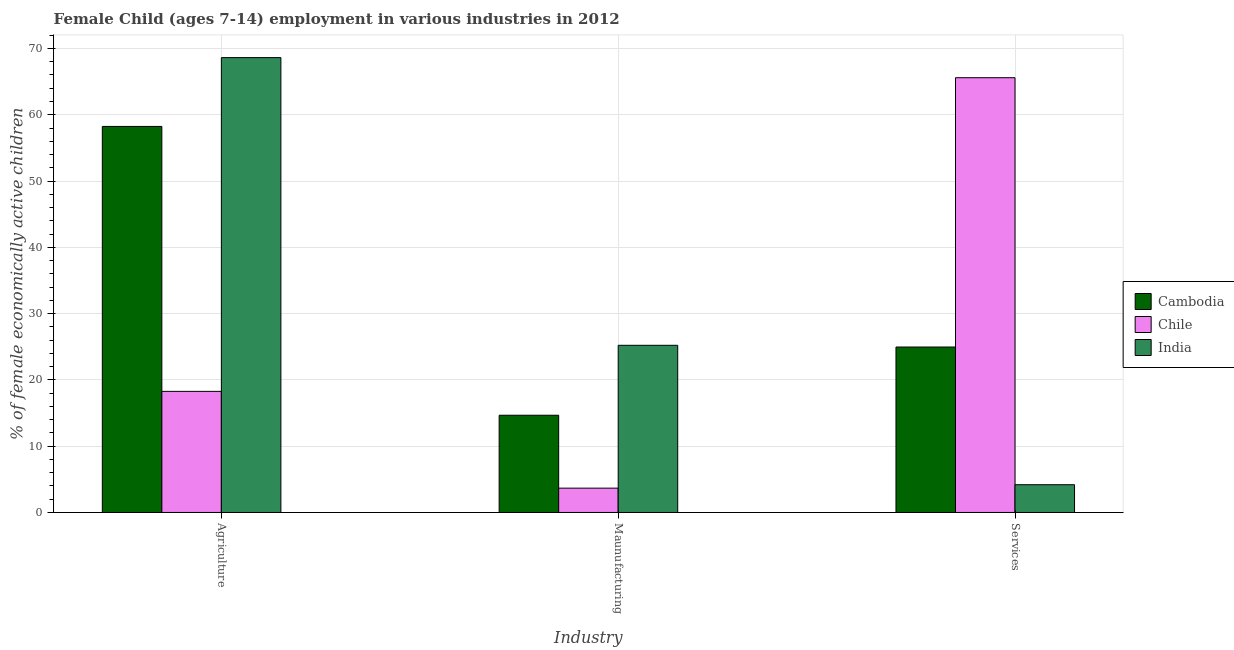How many groups of bars are there?
Give a very brief answer. 3. Are the number of bars per tick equal to the number of legend labels?
Your answer should be very brief. Yes. Are the number of bars on each tick of the X-axis equal?
Give a very brief answer. Yes. How many bars are there on the 1st tick from the left?
Your response must be concise. 3. What is the label of the 1st group of bars from the left?
Your answer should be compact. Agriculture. What is the percentage of economically active children in services in Chile?
Give a very brief answer. 65.59. Across all countries, what is the maximum percentage of economically active children in manufacturing?
Your answer should be very brief. 25.22. Across all countries, what is the minimum percentage of economically active children in agriculture?
Provide a succinct answer. 18.27. What is the total percentage of economically active children in manufacturing in the graph?
Offer a very short reply. 43.56. What is the difference between the percentage of economically active children in agriculture in Chile and that in India?
Offer a very short reply. -50.35. What is the difference between the percentage of economically active children in manufacturing in Chile and the percentage of economically active children in services in India?
Provide a succinct answer. -0.52. What is the average percentage of economically active children in manufacturing per country?
Your answer should be compact. 14.52. What is the difference between the percentage of economically active children in agriculture and percentage of economically active children in services in Cambodia?
Your response must be concise. 33.28. In how many countries, is the percentage of economically active children in services greater than 14 %?
Offer a very short reply. 2. What is the ratio of the percentage of economically active children in services in Cambodia to that in India?
Offer a terse response. 5.96. Is the percentage of economically active children in manufacturing in Cambodia less than that in India?
Offer a very short reply. Yes. Is the difference between the percentage of economically active children in manufacturing in Cambodia and India greater than the difference between the percentage of economically active children in agriculture in Cambodia and India?
Your answer should be very brief. No. What is the difference between the highest and the second highest percentage of economically active children in services?
Your answer should be compact. 40.63. What is the difference between the highest and the lowest percentage of economically active children in agriculture?
Give a very brief answer. 50.35. Is the sum of the percentage of economically active children in manufacturing in Cambodia and Chile greater than the maximum percentage of economically active children in services across all countries?
Your answer should be compact. No. What does the 3rd bar from the left in Services represents?
Your answer should be very brief. India. What does the 3rd bar from the right in Services represents?
Give a very brief answer. Cambodia. Is it the case that in every country, the sum of the percentage of economically active children in agriculture and percentage of economically active children in manufacturing is greater than the percentage of economically active children in services?
Provide a succinct answer. No. How many bars are there?
Your response must be concise. 9. Are all the bars in the graph horizontal?
Provide a succinct answer. No. How many countries are there in the graph?
Offer a very short reply. 3. What is the difference between two consecutive major ticks on the Y-axis?
Keep it short and to the point. 10. Are the values on the major ticks of Y-axis written in scientific E-notation?
Your answer should be compact. No. Does the graph contain any zero values?
Make the answer very short. No. Does the graph contain grids?
Make the answer very short. Yes. Where does the legend appear in the graph?
Give a very brief answer. Center right. What is the title of the graph?
Your answer should be very brief. Female Child (ages 7-14) employment in various industries in 2012. What is the label or title of the X-axis?
Give a very brief answer. Industry. What is the label or title of the Y-axis?
Offer a very short reply. % of female economically active children. What is the % of female economically active children of Cambodia in Agriculture?
Your answer should be very brief. 58.24. What is the % of female economically active children in Chile in Agriculture?
Keep it short and to the point. 18.27. What is the % of female economically active children in India in Agriculture?
Keep it short and to the point. 68.62. What is the % of female economically active children in Cambodia in Maunufacturing?
Keep it short and to the point. 14.67. What is the % of female economically active children of Chile in Maunufacturing?
Keep it short and to the point. 3.67. What is the % of female economically active children in India in Maunufacturing?
Make the answer very short. 25.22. What is the % of female economically active children of Cambodia in Services?
Offer a terse response. 24.96. What is the % of female economically active children in Chile in Services?
Give a very brief answer. 65.59. What is the % of female economically active children in India in Services?
Your answer should be compact. 4.19. Across all Industry, what is the maximum % of female economically active children in Cambodia?
Provide a short and direct response. 58.24. Across all Industry, what is the maximum % of female economically active children in Chile?
Provide a short and direct response. 65.59. Across all Industry, what is the maximum % of female economically active children in India?
Keep it short and to the point. 68.62. Across all Industry, what is the minimum % of female economically active children in Cambodia?
Offer a very short reply. 14.67. Across all Industry, what is the minimum % of female economically active children of Chile?
Keep it short and to the point. 3.67. Across all Industry, what is the minimum % of female economically active children in India?
Your answer should be very brief. 4.19. What is the total % of female economically active children in Cambodia in the graph?
Offer a terse response. 97.87. What is the total % of female economically active children of Chile in the graph?
Offer a very short reply. 87.53. What is the total % of female economically active children in India in the graph?
Offer a terse response. 98.03. What is the difference between the % of female economically active children of Cambodia in Agriculture and that in Maunufacturing?
Keep it short and to the point. 43.57. What is the difference between the % of female economically active children in Chile in Agriculture and that in Maunufacturing?
Your answer should be compact. 14.6. What is the difference between the % of female economically active children in India in Agriculture and that in Maunufacturing?
Provide a succinct answer. 43.4. What is the difference between the % of female economically active children of Cambodia in Agriculture and that in Services?
Offer a very short reply. 33.28. What is the difference between the % of female economically active children of Chile in Agriculture and that in Services?
Offer a terse response. -47.32. What is the difference between the % of female economically active children of India in Agriculture and that in Services?
Ensure brevity in your answer.  64.43. What is the difference between the % of female economically active children in Cambodia in Maunufacturing and that in Services?
Offer a very short reply. -10.29. What is the difference between the % of female economically active children in Chile in Maunufacturing and that in Services?
Offer a very short reply. -61.92. What is the difference between the % of female economically active children in India in Maunufacturing and that in Services?
Your response must be concise. 21.03. What is the difference between the % of female economically active children in Cambodia in Agriculture and the % of female economically active children in Chile in Maunufacturing?
Provide a succinct answer. 54.57. What is the difference between the % of female economically active children of Cambodia in Agriculture and the % of female economically active children of India in Maunufacturing?
Your answer should be compact. 33.02. What is the difference between the % of female economically active children of Chile in Agriculture and the % of female economically active children of India in Maunufacturing?
Your response must be concise. -6.95. What is the difference between the % of female economically active children of Cambodia in Agriculture and the % of female economically active children of Chile in Services?
Make the answer very short. -7.35. What is the difference between the % of female economically active children of Cambodia in Agriculture and the % of female economically active children of India in Services?
Your answer should be compact. 54.05. What is the difference between the % of female economically active children in Chile in Agriculture and the % of female economically active children in India in Services?
Ensure brevity in your answer.  14.08. What is the difference between the % of female economically active children in Cambodia in Maunufacturing and the % of female economically active children in Chile in Services?
Offer a very short reply. -50.92. What is the difference between the % of female economically active children in Cambodia in Maunufacturing and the % of female economically active children in India in Services?
Keep it short and to the point. 10.48. What is the difference between the % of female economically active children of Chile in Maunufacturing and the % of female economically active children of India in Services?
Offer a terse response. -0.52. What is the average % of female economically active children in Cambodia per Industry?
Offer a very short reply. 32.62. What is the average % of female economically active children of Chile per Industry?
Your answer should be compact. 29.18. What is the average % of female economically active children of India per Industry?
Provide a short and direct response. 32.68. What is the difference between the % of female economically active children in Cambodia and % of female economically active children in Chile in Agriculture?
Make the answer very short. 39.97. What is the difference between the % of female economically active children in Cambodia and % of female economically active children in India in Agriculture?
Your answer should be compact. -10.38. What is the difference between the % of female economically active children in Chile and % of female economically active children in India in Agriculture?
Provide a succinct answer. -50.35. What is the difference between the % of female economically active children of Cambodia and % of female economically active children of India in Maunufacturing?
Make the answer very short. -10.55. What is the difference between the % of female economically active children in Chile and % of female economically active children in India in Maunufacturing?
Give a very brief answer. -21.55. What is the difference between the % of female economically active children of Cambodia and % of female economically active children of Chile in Services?
Make the answer very short. -40.63. What is the difference between the % of female economically active children of Cambodia and % of female economically active children of India in Services?
Your answer should be very brief. 20.77. What is the difference between the % of female economically active children in Chile and % of female economically active children in India in Services?
Your response must be concise. 61.4. What is the ratio of the % of female economically active children in Cambodia in Agriculture to that in Maunufacturing?
Provide a succinct answer. 3.97. What is the ratio of the % of female economically active children of Chile in Agriculture to that in Maunufacturing?
Offer a very short reply. 4.98. What is the ratio of the % of female economically active children in India in Agriculture to that in Maunufacturing?
Offer a terse response. 2.72. What is the ratio of the % of female economically active children in Cambodia in Agriculture to that in Services?
Your response must be concise. 2.33. What is the ratio of the % of female economically active children of Chile in Agriculture to that in Services?
Your answer should be compact. 0.28. What is the ratio of the % of female economically active children of India in Agriculture to that in Services?
Your response must be concise. 16.38. What is the ratio of the % of female economically active children of Cambodia in Maunufacturing to that in Services?
Make the answer very short. 0.59. What is the ratio of the % of female economically active children in Chile in Maunufacturing to that in Services?
Offer a terse response. 0.06. What is the ratio of the % of female economically active children of India in Maunufacturing to that in Services?
Make the answer very short. 6.02. What is the difference between the highest and the second highest % of female economically active children of Cambodia?
Keep it short and to the point. 33.28. What is the difference between the highest and the second highest % of female economically active children of Chile?
Offer a terse response. 47.32. What is the difference between the highest and the second highest % of female economically active children in India?
Offer a very short reply. 43.4. What is the difference between the highest and the lowest % of female economically active children in Cambodia?
Give a very brief answer. 43.57. What is the difference between the highest and the lowest % of female economically active children of Chile?
Give a very brief answer. 61.92. What is the difference between the highest and the lowest % of female economically active children of India?
Provide a succinct answer. 64.43. 